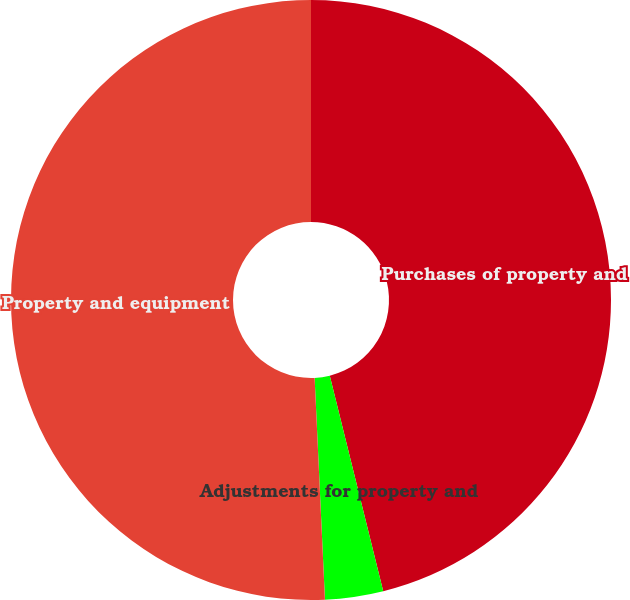<chart> <loc_0><loc_0><loc_500><loc_500><pie_chart><fcel>Purchases of property and<fcel>Adjustments for property and<fcel>Property and equipment<nl><fcel>46.13%<fcel>3.13%<fcel>50.74%<nl></chart> 